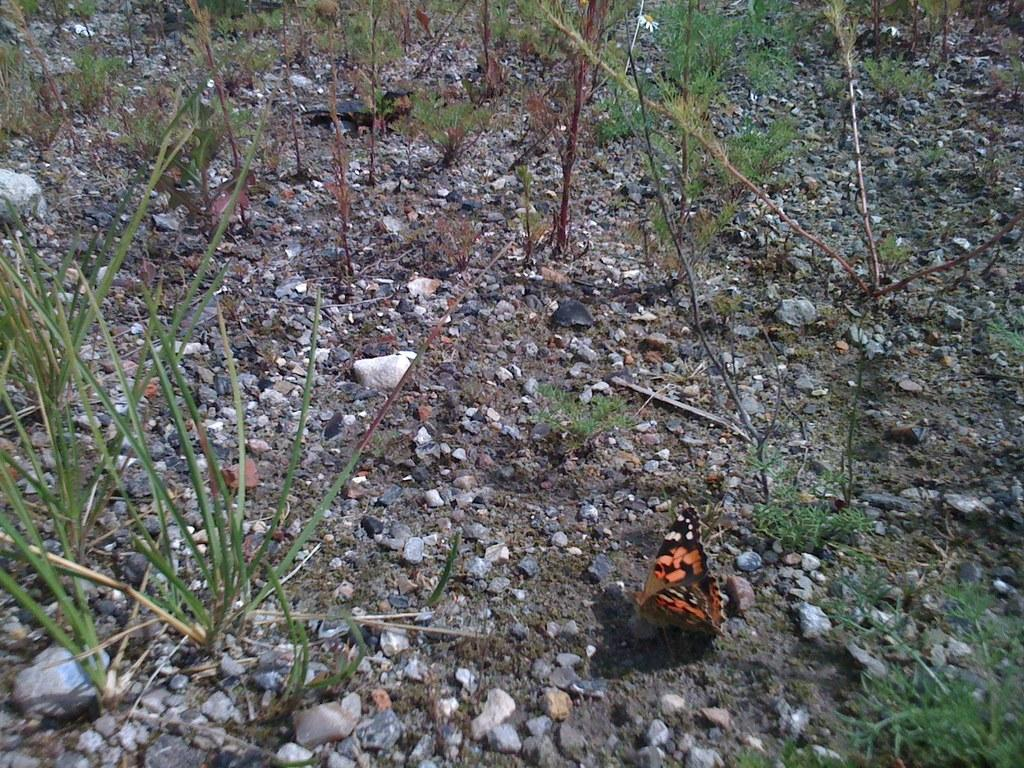What type of animal can be seen in the picture? There is a butterfly in the picture. What other objects or elements are present in the picture? There are stones, grass, and plants in the picture. How does the dirt in the picture twist around the plants? There is no dirt present in the image; it features a butterfly, stones, grass, and plants. 